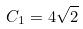<formula> <loc_0><loc_0><loc_500><loc_500>C _ { 1 } = 4 \sqrt { 2 }</formula> 